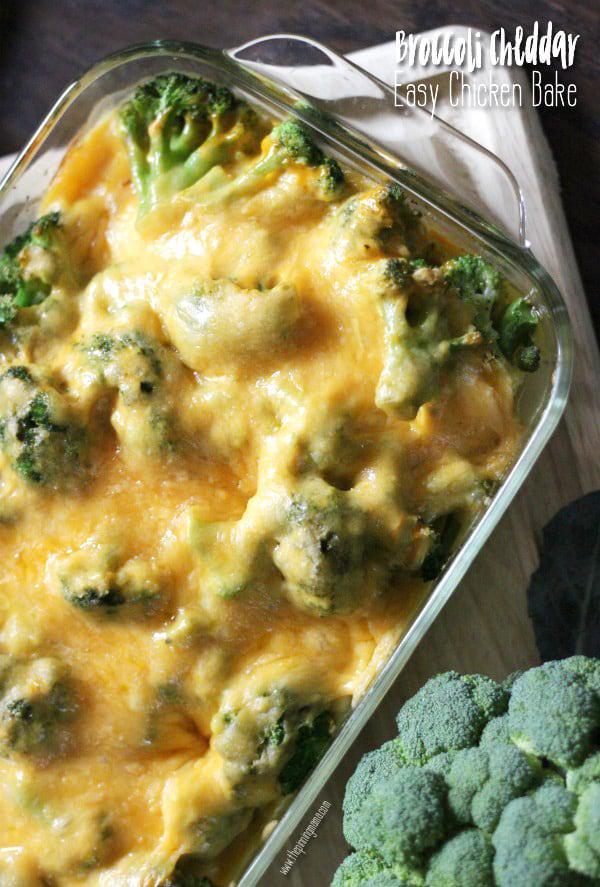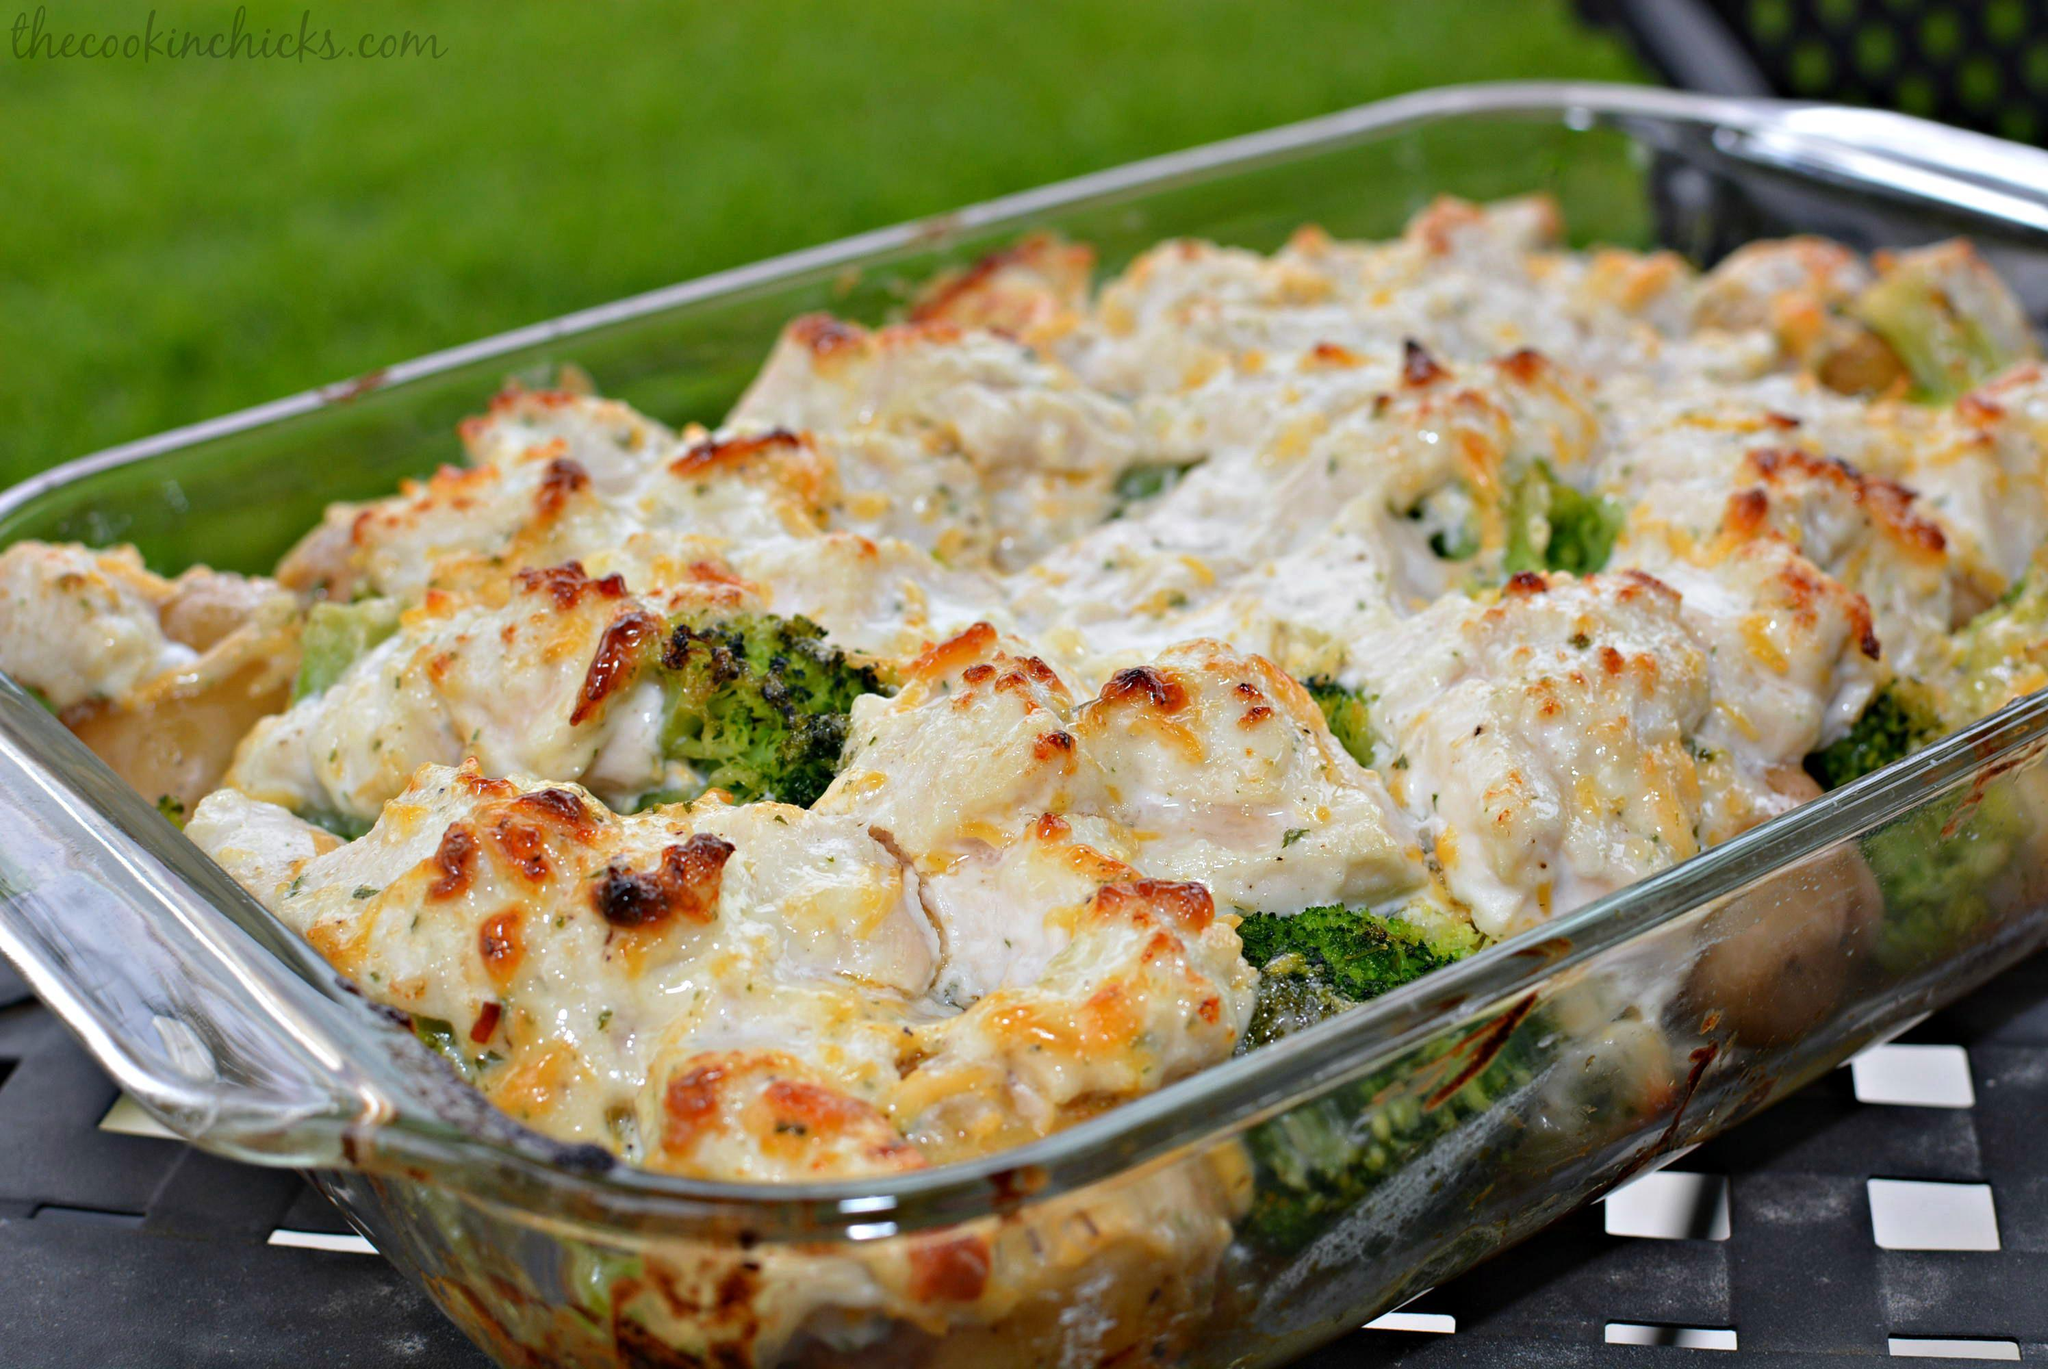The first image is the image on the left, the second image is the image on the right. For the images shown, is this caption "Both images show food served on an all-white dish." true? Answer yes or no. No. The first image is the image on the left, the second image is the image on the right. Analyze the images presented: Is the assertion "The food is one a white plate in the image on the left." valid? Answer yes or no. No. 